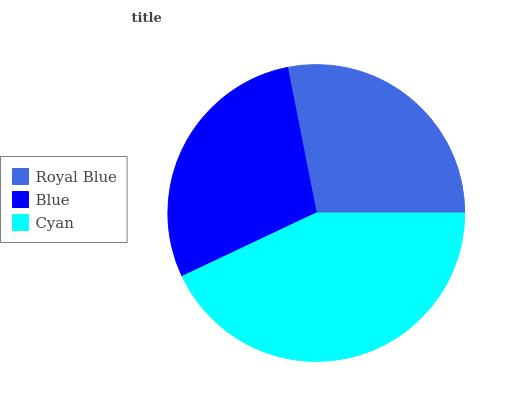Is Royal Blue the minimum?
Answer yes or no. Yes. Is Cyan the maximum?
Answer yes or no. Yes. Is Blue the minimum?
Answer yes or no. No. Is Blue the maximum?
Answer yes or no. No. Is Blue greater than Royal Blue?
Answer yes or no. Yes. Is Royal Blue less than Blue?
Answer yes or no. Yes. Is Royal Blue greater than Blue?
Answer yes or no. No. Is Blue less than Royal Blue?
Answer yes or no. No. Is Blue the high median?
Answer yes or no. Yes. Is Blue the low median?
Answer yes or no. Yes. Is Cyan the high median?
Answer yes or no. No. Is Royal Blue the low median?
Answer yes or no. No. 